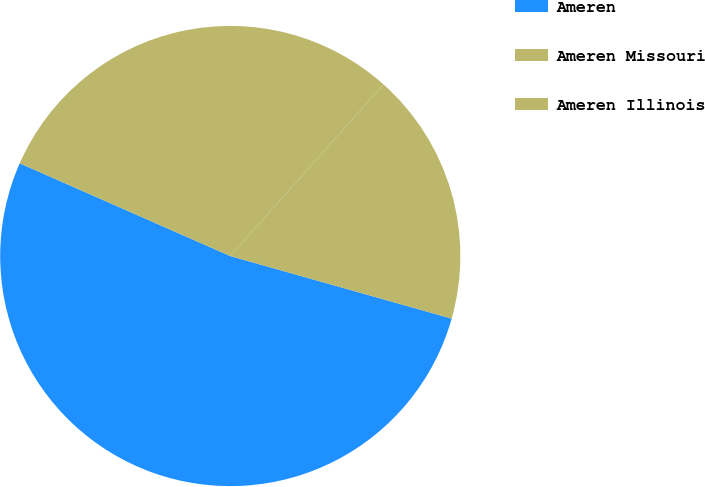Convert chart to OTSL. <chart><loc_0><loc_0><loc_500><loc_500><pie_chart><fcel>Ameren<fcel>Ameren Missouri<fcel>Ameren Illinois<nl><fcel>52.22%<fcel>17.78%<fcel>30.0%<nl></chart> 